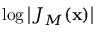Convert formula to latex. <formula><loc_0><loc_0><loc_500><loc_500>\log { \left | { J _ { M } ( x ) } \right | }</formula> 